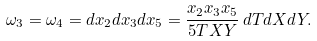Convert formula to latex. <formula><loc_0><loc_0><loc_500><loc_500>\omega _ { 3 } = \omega _ { 4 } = d x _ { 2 } d x _ { 3 } d x _ { 5 } = \frac { x _ { 2 } x _ { 3 } x _ { 5 } } { 5 T X Y } \, d T d X d Y .</formula> 